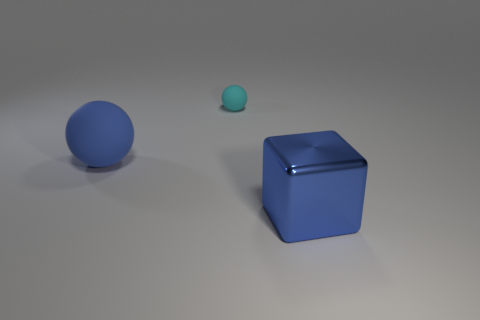There is a thing that is both in front of the small cyan ball and to the right of the large sphere; what shape is it?
Make the answer very short. Cube. The big blue shiny thing that is in front of the sphere behind the big thing that is behind the large blue shiny cube is what shape?
Offer a terse response. Cube. The thing that is both in front of the cyan thing and right of the large matte object is made of what material?
Your answer should be compact. Metal. What number of cyan rubber balls have the same size as the metal cube?
Your answer should be compact. 0. What number of rubber things are big blue things or red cylinders?
Your answer should be compact. 1. What is the cube made of?
Offer a very short reply. Metal. What number of shiny cubes are left of the blue shiny thing?
Make the answer very short. 0. Is the object that is behind the big blue matte thing made of the same material as the blue cube?
Provide a short and direct response. No. How many blue things have the same shape as the cyan rubber thing?
Ensure brevity in your answer.  1. What number of big things are either cyan things or blue objects?
Provide a succinct answer. 2. 